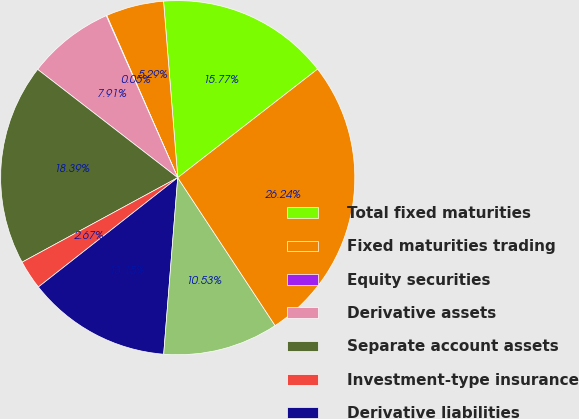<chart> <loc_0><loc_0><loc_500><loc_500><pie_chart><fcel>Total fixed maturities<fcel>Fixed maturities trading<fcel>Equity securities<fcel>Derivative assets<fcel>Separate account assets<fcel>Investment-type insurance<fcel>Derivative liabilities<fcel>Other liabilities<fcel>Net total<nl><fcel>15.77%<fcel>5.29%<fcel>0.05%<fcel>7.91%<fcel>18.39%<fcel>2.67%<fcel>13.15%<fcel>10.53%<fcel>26.24%<nl></chart> 